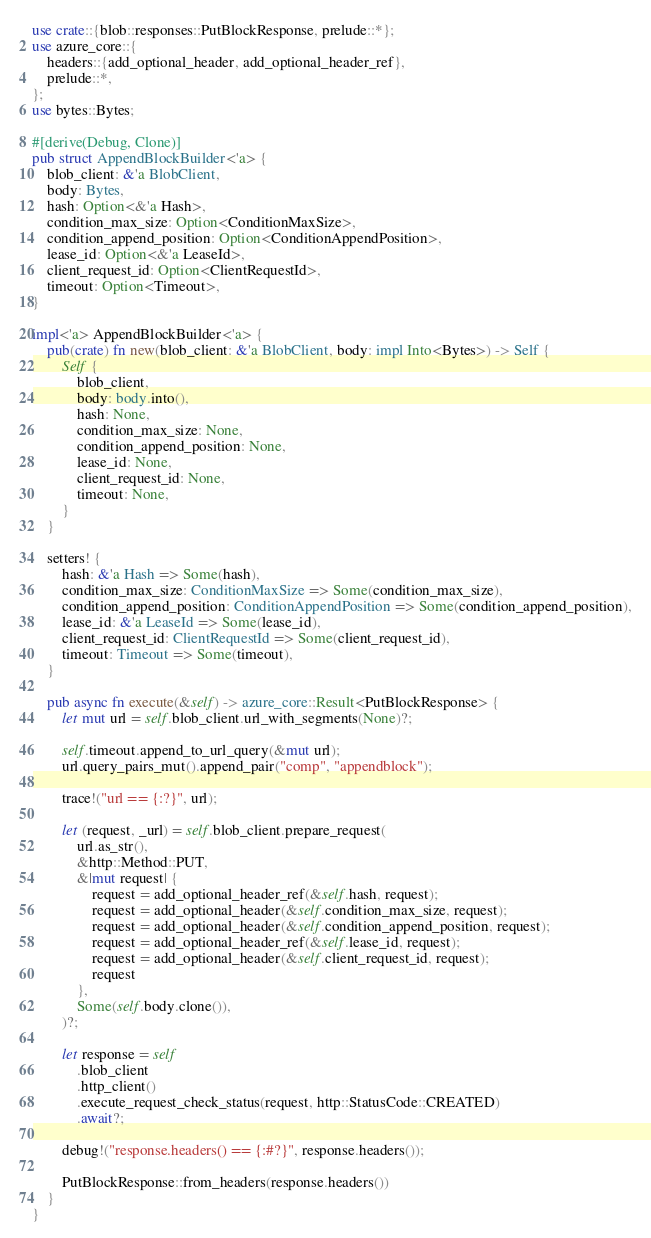Convert code to text. <code><loc_0><loc_0><loc_500><loc_500><_Rust_>use crate::{blob::responses::PutBlockResponse, prelude::*};
use azure_core::{
    headers::{add_optional_header, add_optional_header_ref},
    prelude::*,
};
use bytes::Bytes;

#[derive(Debug, Clone)]
pub struct AppendBlockBuilder<'a> {
    blob_client: &'a BlobClient,
    body: Bytes,
    hash: Option<&'a Hash>,
    condition_max_size: Option<ConditionMaxSize>,
    condition_append_position: Option<ConditionAppendPosition>,
    lease_id: Option<&'a LeaseId>,
    client_request_id: Option<ClientRequestId>,
    timeout: Option<Timeout>,
}

impl<'a> AppendBlockBuilder<'a> {
    pub(crate) fn new(blob_client: &'a BlobClient, body: impl Into<Bytes>) -> Self {
        Self {
            blob_client,
            body: body.into(),
            hash: None,
            condition_max_size: None,
            condition_append_position: None,
            lease_id: None,
            client_request_id: None,
            timeout: None,
        }
    }

    setters! {
        hash: &'a Hash => Some(hash),
        condition_max_size: ConditionMaxSize => Some(condition_max_size),
        condition_append_position: ConditionAppendPosition => Some(condition_append_position),
        lease_id: &'a LeaseId => Some(lease_id),
        client_request_id: ClientRequestId => Some(client_request_id),
        timeout: Timeout => Some(timeout),
    }

    pub async fn execute(&self) -> azure_core::Result<PutBlockResponse> {
        let mut url = self.blob_client.url_with_segments(None)?;

        self.timeout.append_to_url_query(&mut url);
        url.query_pairs_mut().append_pair("comp", "appendblock");

        trace!("url == {:?}", url);

        let (request, _url) = self.blob_client.prepare_request(
            url.as_str(),
            &http::Method::PUT,
            &|mut request| {
                request = add_optional_header_ref(&self.hash, request);
                request = add_optional_header(&self.condition_max_size, request);
                request = add_optional_header(&self.condition_append_position, request);
                request = add_optional_header_ref(&self.lease_id, request);
                request = add_optional_header(&self.client_request_id, request);
                request
            },
            Some(self.body.clone()),
        )?;

        let response = self
            .blob_client
            .http_client()
            .execute_request_check_status(request, http::StatusCode::CREATED)
            .await?;

        debug!("response.headers() == {:#?}", response.headers());

        PutBlockResponse::from_headers(response.headers())
    }
}
</code> 